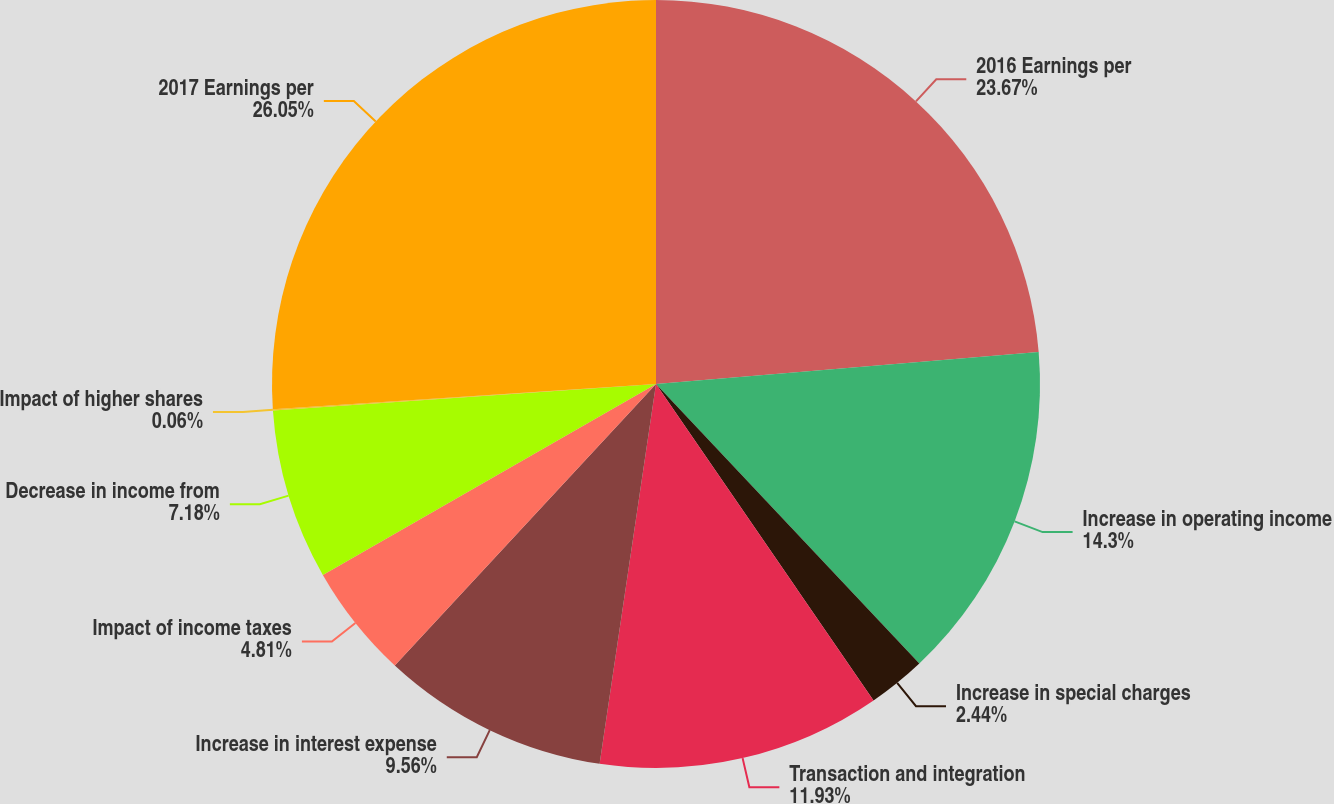<chart> <loc_0><loc_0><loc_500><loc_500><pie_chart><fcel>2016 Earnings per<fcel>Increase in operating income<fcel>Increase in special charges<fcel>Transaction and integration<fcel>Increase in interest expense<fcel>Impact of income taxes<fcel>Decrease in income from<fcel>Impact of higher shares<fcel>2017 Earnings per<nl><fcel>23.67%<fcel>14.3%<fcel>2.44%<fcel>11.93%<fcel>9.56%<fcel>4.81%<fcel>7.18%<fcel>0.06%<fcel>26.04%<nl></chart> 